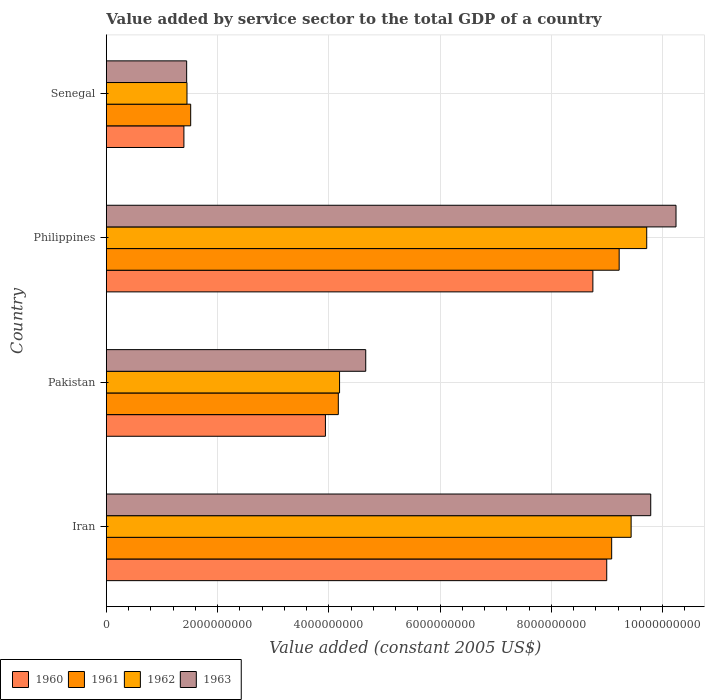How many different coloured bars are there?
Make the answer very short. 4. Are the number of bars per tick equal to the number of legend labels?
Your answer should be very brief. Yes. Are the number of bars on each tick of the Y-axis equal?
Your response must be concise. Yes. How many bars are there on the 2nd tick from the top?
Provide a succinct answer. 4. What is the label of the 3rd group of bars from the top?
Your response must be concise. Pakistan. In how many cases, is the number of bars for a given country not equal to the number of legend labels?
Your answer should be compact. 0. What is the value added by service sector in 1960 in Senegal?
Your response must be concise. 1.39e+09. Across all countries, what is the maximum value added by service sector in 1962?
Your answer should be compact. 9.72e+09. Across all countries, what is the minimum value added by service sector in 1962?
Provide a succinct answer. 1.45e+09. In which country was the value added by service sector in 1963 minimum?
Offer a very short reply. Senegal. What is the total value added by service sector in 1963 in the graph?
Provide a succinct answer. 2.61e+1. What is the difference between the value added by service sector in 1962 in Pakistan and that in Senegal?
Your response must be concise. 2.74e+09. What is the difference between the value added by service sector in 1963 in Senegal and the value added by service sector in 1961 in Philippines?
Make the answer very short. -7.78e+09. What is the average value added by service sector in 1963 per country?
Ensure brevity in your answer.  6.53e+09. What is the difference between the value added by service sector in 1960 and value added by service sector in 1963 in Philippines?
Your answer should be compact. -1.49e+09. What is the ratio of the value added by service sector in 1962 in Iran to that in Pakistan?
Provide a short and direct response. 2.25. Is the value added by service sector in 1962 in Philippines less than that in Senegal?
Your answer should be very brief. No. What is the difference between the highest and the second highest value added by service sector in 1960?
Make the answer very short. 2.49e+08. What is the difference between the highest and the lowest value added by service sector in 1961?
Keep it short and to the point. 7.70e+09. In how many countries, is the value added by service sector in 1963 greater than the average value added by service sector in 1963 taken over all countries?
Make the answer very short. 2. What does the 3rd bar from the bottom in Senegal represents?
Offer a terse response. 1962. How many bars are there?
Provide a succinct answer. 16. How many countries are there in the graph?
Your answer should be very brief. 4. What is the difference between two consecutive major ticks on the X-axis?
Your answer should be compact. 2.00e+09. Does the graph contain grids?
Make the answer very short. Yes. Where does the legend appear in the graph?
Offer a terse response. Bottom left. What is the title of the graph?
Make the answer very short. Value added by service sector to the total GDP of a country. What is the label or title of the X-axis?
Your answer should be very brief. Value added (constant 2005 US$). What is the label or title of the Y-axis?
Your answer should be very brief. Country. What is the Value added (constant 2005 US$) in 1960 in Iran?
Offer a very short reply. 9.00e+09. What is the Value added (constant 2005 US$) of 1961 in Iran?
Ensure brevity in your answer.  9.09e+09. What is the Value added (constant 2005 US$) in 1962 in Iran?
Provide a succinct answer. 9.44e+09. What is the Value added (constant 2005 US$) in 1963 in Iran?
Give a very brief answer. 9.79e+09. What is the Value added (constant 2005 US$) in 1960 in Pakistan?
Your answer should be very brief. 3.94e+09. What is the Value added (constant 2005 US$) of 1961 in Pakistan?
Provide a short and direct response. 4.17e+09. What is the Value added (constant 2005 US$) in 1962 in Pakistan?
Make the answer very short. 4.19e+09. What is the Value added (constant 2005 US$) of 1963 in Pakistan?
Provide a succinct answer. 4.66e+09. What is the Value added (constant 2005 US$) in 1960 in Philippines?
Offer a very short reply. 8.75e+09. What is the Value added (constant 2005 US$) in 1961 in Philippines?
Ensure brevity in your answer.  9.22e+09. What is the Value added (constant 2005 US$) in 1962 in Philippines?
Offer a very short reply. 9.72e+09. What is the Value added (constant 2005 US$) of 1963 in Philippines?
Keep it short and to the point. 1.02e+1. What is the Value added (constant 2005 US$) in 1960 in Senegal?
Offer a very short reply. 1.39e+09. What is the Value added (constant 2005 US$) in 1961 in Senegal?
Keep it short and to the point. 1.52e+09. What is the Value added (constant 2005 US$) of 1962 in Senegal?
Your answer should be compact. 1.45e+09. What is the Value added (constant 2005 US$) of 1963 in Senegal?
Offer a terse response. 1.44e+09. Across all countries, what is the maximum Value added (constant 2005 US$) in 1960?
Ensure brevity in your answer.  9.00e+09. Across all countries, what is the maximum Value added (constant 2005 US$) in 1961?
Offer a terse response. 9.22e+09. Across all countries, what is the maximum Value added (constant 2005 US$) in 1962?
Offer a very short reply. 9.72e+09. Across all countries, what is the maximum Value added (constant 2005 US$) in 1963?
Provide a succinct answer. 1.02e+1. Across all countries, what is the minimum Value added (constant 2005 US$) in 1960?
Your answer should be very brief. 1.39e+09. Across all countries, what is the minimum Value added (constant 2005 US$) in 1961?
Give a very brief answer. 1.52e+09. Across all countries, what is the minimum Value added (constant 2005 US$) in 1962?
Give a very brief answer. 1.45e+09. Across all countries, what is the minimum Value added (constant 2005 US$) in 1963?
Give a very brief answer. 1.44e+09. What is the total Value added (constant 2005 US$) of 1960 in the graph?
Your answer should be very brief. 2.31e+1. What is the total Value added (constant 2005 US$) of 1961 in the graph?
Ensure brevity in your answer.  2.40e+1. What is the total Value added (constant 2005 US$) of 1962 in the graph?
Your answer should be compact. 2.48e+1. What is the total Value added (constant 2005 US$) of 1963 in the graph?
Offer a very short reply. 2.61e+1. What is the difference between the Value added (constant 2005 US$) in 1960 in Iran and that in Pakistan?
Ensure brevity in your answer.  5.06e+09. What is the difference between the Value added (constant 2005 US$) of 1961 in Iran and that in Pakistan?
Your response must be concise. 4.92e+09. What is the difference between the Value added (constant 2005 US$) in 1962 in Iran and that in Pakistan?
Keep it short and to the point. 5.24e+09. What is the difference between the Value added (constant 2005 US$) of 1963 in Iran and that in Pakistan?
Keep it short and to the point. 5.12e+09. What is the difference between the Value added (constant 2005 US$) of 1960 in Iran and that in Philippines?
Provide a succinct answer. 2.49e+08. What is the difference between the Value added (constant 2005 US$) in 1961 in Iran and that in Philippines?
Provide a succinct answer. -1.35e+08. What is the difference between the Value added (constant 2005 US$) in 1962 in Iran and that in Philippines?
Give a very brief answer. -2.80e+08. What is the difference between the Value added (constant 2005 US$) of 1963 in Iran and that in Philippines?
Ensure brevity in your answer.  -4.54e+08. What is the difference between the Value added (constant 2005 US$) in 1960 in Iran and that in Senegal?
Offer a very short reply. 7.60e+09. What is the difference between the Value added (constant 2005 US$) in 1961 in Iran and that in Senegal?
Your answer should be very brief. 7.57e+09. What is the difference between the Value added (constant 2005 US$) in 1962 in Iran and that in Senegal?
Ensure brevity in your answer.  7.99e+09. What is the difference between the Value added (constant 2005 US$) in 1963 in Iran and that in Senegal?
Your response must be concise. 8.34e+09. What is the difference between the Value added (constant 2005 US$) of 1960 in Pakistan and that in Philippines?
Ensure brevity in your answer.  -4.81e+09. What is the difference between the Value added (constant 2005 US$) in 1961 in Pakistan and that in Philippines?
Your response must be concise. -5.05e+09. What is the difference between the Value added (constant 2005 US$) of 1962 in Pakistan and that in Philippines?
Provide a succinct answer. -5.52e+09. What is the difference between the Value added (constant 2005 US$) in 1963 in Pakistan and that in Philippines?
Provide a short and direct response. -5.58e+09. What is the difference between the Value added (constant 2005 US$) of 1960 in Pakistan and that in Senegal?
Offer a very short reply. 2.54e+09. What is the difference between the Value added (constant 2005 US$) of 1961 in Pakistan and that in Senegal?
Offer a terse response. 2.65e+09. What is the difference between the Value added (constant 2005 US$) in 1962 in Pakistan and that in Senegal?
Your answer should be very brief. 2.74e+09. What is the difference between the Value added (constant 2005 US$) of 1963 in Pakistan and that in Senegal?
Your answer should be compact. 3.22e+09. What is the difference between the Value added (constant 2005 US$) in 1960 in Philippines and that in Senegal?
Ensure brevity in your answer.  7.35e+09. What is the difference between the Value added (constant 2005 US$) of 1961 in Philippines and that in Senegal?
Your answer should be very brief. 7.70e+09. What is the difference between the Value added (constant 2005 US$) in 1962 in Philippines and that in Senegal?
Ensure brevity in your answer.  8.27e+09. What is the difference between the Value added (constant 2005 US$) of 1963 in Philippines and that in Senegal?
Your answer should be very brief. 8.80e+09. What is the difference between the Value added (constant 2005 US$) in 1960 in Iran and the Value added (constant 2005 US$) in 1961 in Pakistan?
Provide a short and direct response. 4.83e+09. What is the difference between the Value added (constant 2005 US$) in 1960 in Iran and the Value added (constant 2005 US$) in 1962 in Pakistan?
Your response must be concise. 4.80e+09. What is the difference between the Value added (constant 2005 US$) in 1960 in Iran and the Value added (constant 2005 US$) in 1963 in Pakistan?
Your answer should be compact. 4.33e+09. What is the difference between the Value added (constant 2005 US$) of 1961 in Iran and the Value added (constant 2005 US$) of 1962 in Pakistan?
Offer a very short reply. 4.89e+09. What is the difference between the Value added (constant 2005 US$) of 1961 in Iran and the Value added (constant 2005 US$) of 1963 in Pakistan?
Make the answer very short. 4.42e+09. What is the difference between the Value added (constant 2005 US$) of 1962 in Iran and the Value added (constant 2005 US$) of 1963 in Pakistan?
Keep it short and to the point. 4.77e+09. What is the difference between the Value added (constant 2005 US$) in 1960 in Iran and the Value added (constant 2005 US$) in 1961 in Philippines?
Provide a succinct answer. -2.24e+08. What is the difference between the Value added (constant 2005 US$) in 1960 in Iran and the Value added (constant 2005 US$) in 1962 in Philippines?
Make the answer very short. -7.19e+08. What is the difference between the Value added (constant 2005 US$) in 1960 in Iran and the Value added (constant 2005 US$) in 1963 in Philippines?
Ensure brevity in your answer.  -1.25e+09. What is the difference between the Value added (constant 2005 US$) in 1961 in Iran and the Value added (constant 2005 US$) in 1962 in Philippines?
Ensure brevity in your answer.  -6.30e+08. What is the difference between the Value added (constant 2005 US$) in 1961 in Iran and the Value added (constant 2005 US$) in 1963 in Philippines?
Your answer should be compact. -1.16e+09. What is the difference between the Value added (constant 2005 US$) in 1962 in Iran and the Value added (constant 2005 US$) in 1963 in Philippines?
Provide a short and direct response. -8.07e+08. What is the difference between the Value added (constant 2005 US$) in 1960 in Iran and the Value added (constant 2005 US$) in 1961 in Senegal?
Provide a succinct answer. 7.48e+09. What is the difference between the Value added (constant 2005 US$) in 1960 in Iran and the Value added (constant 2005 US$) in 1962 in Senegal?
Your response must be concise. 7.55e+09. What is the difference between the Value added (constant 2005 US$) of 1960 in Iran and the Value added (constant 2005 US$) of 1963 in Senegal?
Your response must be concise. 7.55e+09. What is the difference between the Value added (constant 2005 US$) in 1961 in Iran and the Value added (constant 2005 US$) in 1962 in Senegal?
Keep it short and to the point. 7.64e+09. What is the difference between the Value added (constant 2005 US$) in 1961 in Iran and the Value added (constant 2005 US$) in 1963 in Senegal?
Make the answer very short. 7.64e+09. What is the difference between the Value added (constant 2005 US$) of 1962 in Iran and the Value added (constant 2005 US$) of 1963 in Senegal?
Give a very brief answer. 7.99e+09. What is the difference between the Value added (constant 2005 US$) of 1960 in Pakistan and the Value added (constant 2005 US$) of 1961 in Philippines?
Provide a succinct answer. -5.28e+09. What is the difference between the Value added (constant 2005 US$) in 1960 in Pakistan and the Value added (constant 2005 US$) in 1962 in Philippines?
Give a very brief answer. -5.78e+09. What is the difference between the Value added (constant 2005 US$) of 1960 in Pakistan and the Value added (constant 2005 US$) of 1963 in Philippines?
Your answer should be very brief. -6.30e+09. What is the difference between the Value added (constant 2005 US$) in 1961 in Pakistan and the Value added (constant 2005 US$) in 1962 in Philippines?
Give a very brief answer. -5.55e+09. What is the difference between the Value added (constant 2005 US$) of 1961 in Pakistan and the Value added (constant 2005 US$) of 1963 in Philippines?
Provide a short and direct response. -6.07e+09. What is the difference between the Value added (constant 2005 US$) of 1962 in Pakistan and the Value added (constant 2005 US$) of 1963 in Philippines?
Your answer should be compact. -6.05e+09. What is the difference between the Value added (constant 2005 US$) in 1960 in Pakistan and the Value added (constant 2005 US$) in 1961 in Senegal?
Provide a succinct answer. 2.42e+09. What is the difference between the Value added (constant 2005 US$) of 1960 in Pakistan and the Value added (constant 2005 US$) of 1962 in Senegal?
Provide a short and direct response. 2.49e+09. What is the difference between the Value added (constant 2005 US$) in 1960 in Pakistan and the Value added (constant 2005 US$) in 1963 in Senegal?
Offer a very short reply. 2.49e+09. What is the difference between the Value added (constant 2005 US$) in 1961 in Pakistan and the Value added (constant 2005 US$) in 1962 in Senegal?
Offer a very short reply. 2.72e+09. What is the difference between the Value added (constant 2005 US$) in 1961 in Pakistan and the Value added (constant 2005 US$) in 1963 in Senegal?
Offer a very short reply. 2.73e+09. What is the difference between the Value added (constant 2005 US$) of 1962 in Pakistan and the Value added (constant 2005 US$) of 1963 in Senegal?
Your answer should be compact. 2.75e+09. What is the difference between the Value added (constant 2005 US$) in 1960 in Philippines and the Value added (constant 2005 US$) in 1961 in Senegal?
Make the answer very short. 7.23e+09. What is the difference between the Value added (constant 2005 US$) of 1960 in Philippines and the Value added (constant 2005 US$) of 1962 in Senegal?
Your response must be concise. 7.30e+09. What is the difference between the Value added (constant 2005 US$) of 1960 in Philippines and the Value added (constant 2005 US$) of 1963 in Senegal?
Offer a very short reply. 7.30e+09. What is the difference between the Value added (constant 2005 US$) of 1961 in Philippines and the Value added (constant 2005 US$) of 1962 in Senegal?
Your response must be concise. 7.77e+09. What is the difference between the Value added (constant 2005 US$) of 1961 in Philippines and the Value added (constant 2005 US$) of 1963 in Senegal?
Offer a very short reply. 7.78e+09. What is the difference between the Value added (constant 2005 US$) of 1962 in Philippines and the Value added (constant 2005 US$) of 1963 in Senegal?
Ensure brevity in your answer.  8.27e+09. What is the average Value added (constant 2005 US$) of 1960 per country?
Keep it short and to the point. 5.77e+09. What is the average Value added (constant 2005 US$) of 1961 per country?
Make the answer very short. 6.00e+09. What is the average Value added (constant 2005 US$) in 1962 per country?
Offer a terse response. 6.20e+09. What is the average Value added (constant 2005 US$) in 1963 per country?
Offer a terse response. 6.53e+09. What is the difference between the Value added (constant 2005 US$) of 1960 and Value added (constant 2005 US$) of 1961 in Iran?
Make the answer very short. -8.88e+07. What is the difference between the Value added (constant 2005 US$) in 1960 and Value added (constant 2005 US$) in 1962 in Iran?
Provide a succinct answer. -4.39e+08. What is the difference between the Value added (constant 2005 US$) of 1960 and Value added (constant 2005 US$) of 1963 in Iran?
Your response must be concise. -7.91e+08. What is the difference between the Value added (constant 2005 US$) of 1961 and Value added (constant 2005 US$) of 1962 in Iran?
Give a very brief answer. -3.50e+08. What is the difference between the Value added (constant 2005 US$) in 1961 and Value added (constant 2005 US$) in 1963 in Iran?
Offer a very short reply. -7.02e+08. What is the difference between the Value added (constant 2005 US$) in 1962 and Value added (constant 2005 US$) in 1963 in Iran?
Your answer should be very brief. -3.52e+08. What is the difference between the Value added (constant 2005 US$) in 1960 and Value added (constant 2005 US$) in 1961 in Pakistan?
Give a very brief answer. -2.32e+08. What is the difference between the Value added (constant 2005 US$) in 1960 and Value added (constant 2005 US$) in 1962 in Pakistan?
Ensure brevity in your answer.  -2.54e+08. What is the difference between the Value added (constant 2005 US$) in 1960 and Value added (constant 2005 US$) in 1963 in Pakistan?
Provide a succinct answer. -7.25e+08. What is the difference between the Value added (constant 2005 US$) in 1961 and Value added (constant 2005 US$) in 1962 in Pakistan?
Your answer should be very brief. -2.26e+07. What is the difference between the Value added (constant 2005 US$) in 1961 and Value added (constant 2005 US$) in 1963 in Pakistan?
Keep it short and to the point. -4.93e+08. What is the difference between the Value added (constant 2005 US$) in 1962 and Value added (constant 2005 US$) in 1963 in Pakistan?
Give a very brief answer. -4.71e+08. What is the difference between the Value added (constant 2005 US$) of 1960 and Value added (constant 2005 US$) of 1961 in Philippines?
Provide a short and direct response. -4.73e+08. What is the difference between the Value added (constant 2005 US$) in 1960 and Value added (constant 2005 US$) in 1962 in Philippines?
Your answer should be very brief. -9.68e+08. What is the difference between the Value added (constant 2005 US$) in 1960 and Value added (constant 2005 US$) in 1963 in Philippines?
Give a very brief answer. -1.49e+09. What is the difference between the Value added (constant 2005 US$) in 1961 and Value added (constant 2005 US$) in 1962 in Philippines?
Ensure brevity in your answer.  -4.95e+08. What is the difference between the Value added (constant 2005 US$) of 1961 and Value added (constant 2005 US$) of 1963 in Philippines?
Your response must be concise. -1.02e+09. What is the difference between the Value added (constant 2005 US$) in 1962 and Value added (constant 2005 US$) in 1963 in Philippines?
Your answer should be very brief. -5.27e+08. What is the difference between the Value added (constant 2005 US$) in 1960 and Value added (constant 2005 US$) in 1961 in Senegal?
Provide a succinct answer. -1.22e+08. What is the difference between the Value added (constant 2005 US$) in 1960 and Value added (constant 2005 US$) in 1962 in Senegal?
Give a very brief answer. -5.52e+07. What is the difference between the Value added (constant 2005 US$) of 1960 and Value added (constant 2005 US$) of 1963 in Senegal?
Offer a terse response. -4.94e+07. What is the difference between the Value added (constant 2005 US$) of 1961 and Value added (constant 2005 US$) of 1962 in Senegal?
Make the answer very short. 6.67e+07. What is the difference between the Value added (constant 2005 US$) of 1961 and Value added (constant 2005 US$) of 1963 in Senegal?
Your answer should be compact. 7.25e+07. What is the difference between the Value added (constant 2005 US$) in 1962 and Value added (constant 2005 US$) in 1963 in Senegal?
Ensure brevity in your answer.  5.77e+06. What is the ratio of the Value added (constant 2005 US$) in 1960 in Iran to that in Pakistan?
Your answer should be very brief. 2.28. What is the ratio of the Value added (constant 2005 US$) of 1961 in Iran to that in Pakistan?
Ensure brevity in your answer.  2.18. What is the ratio of the Value added (constant 2005 US$) in 1962 in Iran to that in Pakistan?
Provide a short and direct response. 2.25. What is the ratio of the Value added (constant 2005 US$) in 1963 in Iran to that in Pakistan?
Keep it short and to the point. 2.1. What is the ratio of the Value added (constant 2005 US$) in 1960 in Iran to that in Philippines?
Your answer should be very brief. 1.03. What is the ratio of the Value added (constant 2005 US$) in 1961 in Iran to that in Philippines?
Keep it short and to the point. 0.99. What is the ratio of the Value added (constant 2005 US$) of 1962 in Iran to that in Philippines?
Ensure brevity in your answer.  0.97. What is the ratio of the Value added (constant 2005 US$) in 1963 in Iran to that in Philippines?
Provide a short and direct response. 0.96. What is the ratio of the Value added (constant 2005 US$) of 1960 in Iran to that in Senegal?
Your answer should be very brief. 6.45. What is the ratio of the Value added (constant 2005 US$) in 1961 in Iran to that in Senegal?
Your response must be concise. 5.99. What is the ratio of the Value added (constant 2005 US$) in 1962 in Iran to that in Senegal?
Your response must be concise. 6.51. What is the ratio of the Value added (constant 2005 US$) of 1963 in Iran to that in Senegal?
Provide a succinct answer. 6.78. What is the ratio of the Value added (constant 2005 US$) of 1960 in Pakistan to that in Philippines?
Provide a succinct answer. 0.45. What is the ratio of the Value added (constant 2005 US$) in 1961 in Pakistan to that in Philippines?
Ensure brevity in your answer.  0.45. What is the ratio of the Value added (constant 2005 US$) of 1962 in Pakistan to that in Philippines?
Give a very brief answer. 0.43. What is the ratio of the Value added (constant 2005 US$) in 1963 in Pakistan to that in Philippines?
Your answer should be very brief. 0.46. What is the ratio of the Value added (constant 2005 US$) of 1960 in Pakistan to that in Senegal?
Offer a terse response. 2.82. What is the ratio of the Value added (constant 2005 US$) in 1961 in Pakistan to that in Senegal?
Ensure brevity in your answer.  2.75. What is the ratio of the Value added (constant 2005 US$) of 1962 in Pakistan to that in Senegal?
Your answer should be compact. 2.89. What is the ratio of the Value added (constant 2005 US$) in 1963 in Pakistan to that in Senegal?
Keep it short and to the point. 3.23. What is the ratio of the Value added (constant 2005 US$) in 1960 in Philippines to that in Senegal?
Make the answer very short. 6.27. What is the ratio of the Value added (constant 2005 US$) of 1961 in Philippines to that in Senegal?
Provide a short and direct response. 6.08. What is the ratio of the Value added (constant 2005 US$) in 1962 in Philippines to that in Senegal?
Ensure brevity in your answer.  6.7. What is the ratio of the Value added (constant 2005 US$) of 1963 in Philippines to that in Senegal?
Your answer should be compact. 7.09. What is the difference between the highest and the second highest Value added (constant 2005 US$) of 1960?
Offer a terse response. 2.49e+08. What is the difference between the highest and the second highest Value added (constant 2005 US$) in 1961?
Offer a terse response. 1.35e+08. What is the difference between the highest and the second highest Value added (constant 2005 US$) of 1962?
Provide a succinct answer. 2.80e+08. What is the difference between the highest and the second highest Value added (constant 2005 US$) of 1963?
Provide a succinct answer. 4.54e+08. What is the difference between the highest and the lowest Value added (constant 2005 US$) in 1960?
Give a very brief answer. 7.60e+09. What is the difference between the highest and the lowest Value added (constant 2005 US$) in 1961?
Offer a very short reply. 7.70e+09. What is the difference between the highest and the lowest Value added (constant 2005 US$) of 1962?
Keep it short and to the point. 8.27e+09. What is the difference between the highest and the lowest Value added (constant 2005 US$) of 1963?
Offer a terse response. 8.80e+09. 